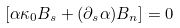Convert formula to latex. <formula><loc_0><loc_0><loc_500><loc_500>[ { \alpha } { \kappa } _ { 0 } B _ { s } + ( { \partial } _ { s } { \alpha } ) B _ { n } ] = 0</formula> 